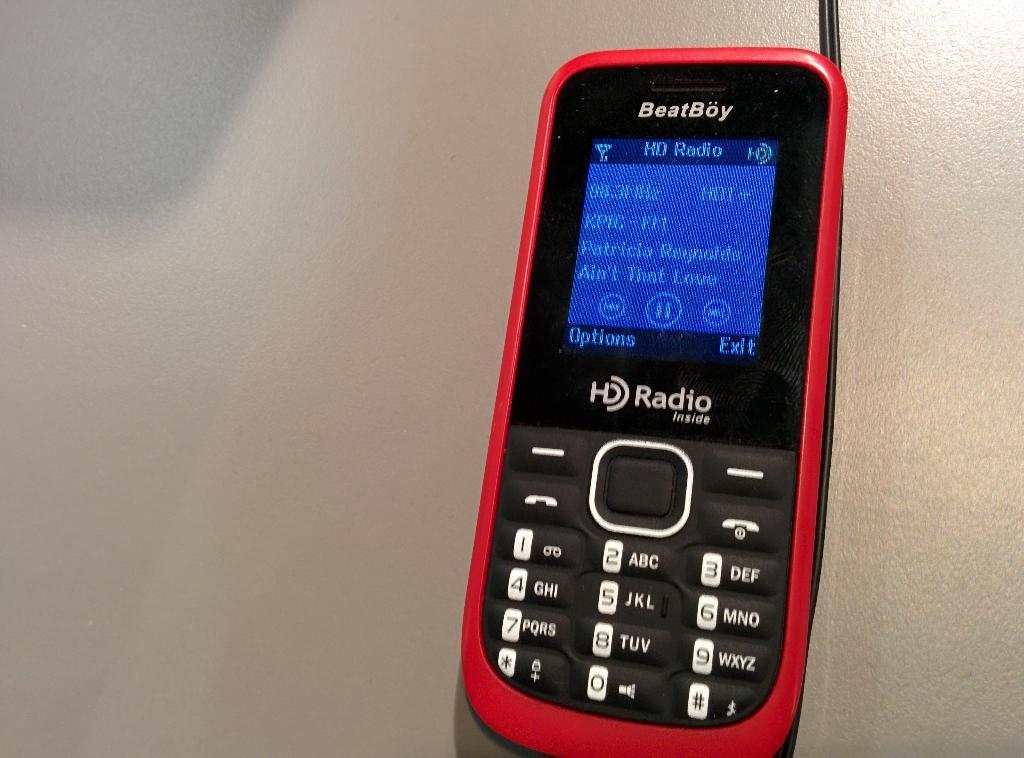What object is present in the image? There is a mobile in the image. Where is the mobile located? The mobile is on a surface. What type of writing can be seen on the mobile in the image? There is no writing present on the mobile in the image. 